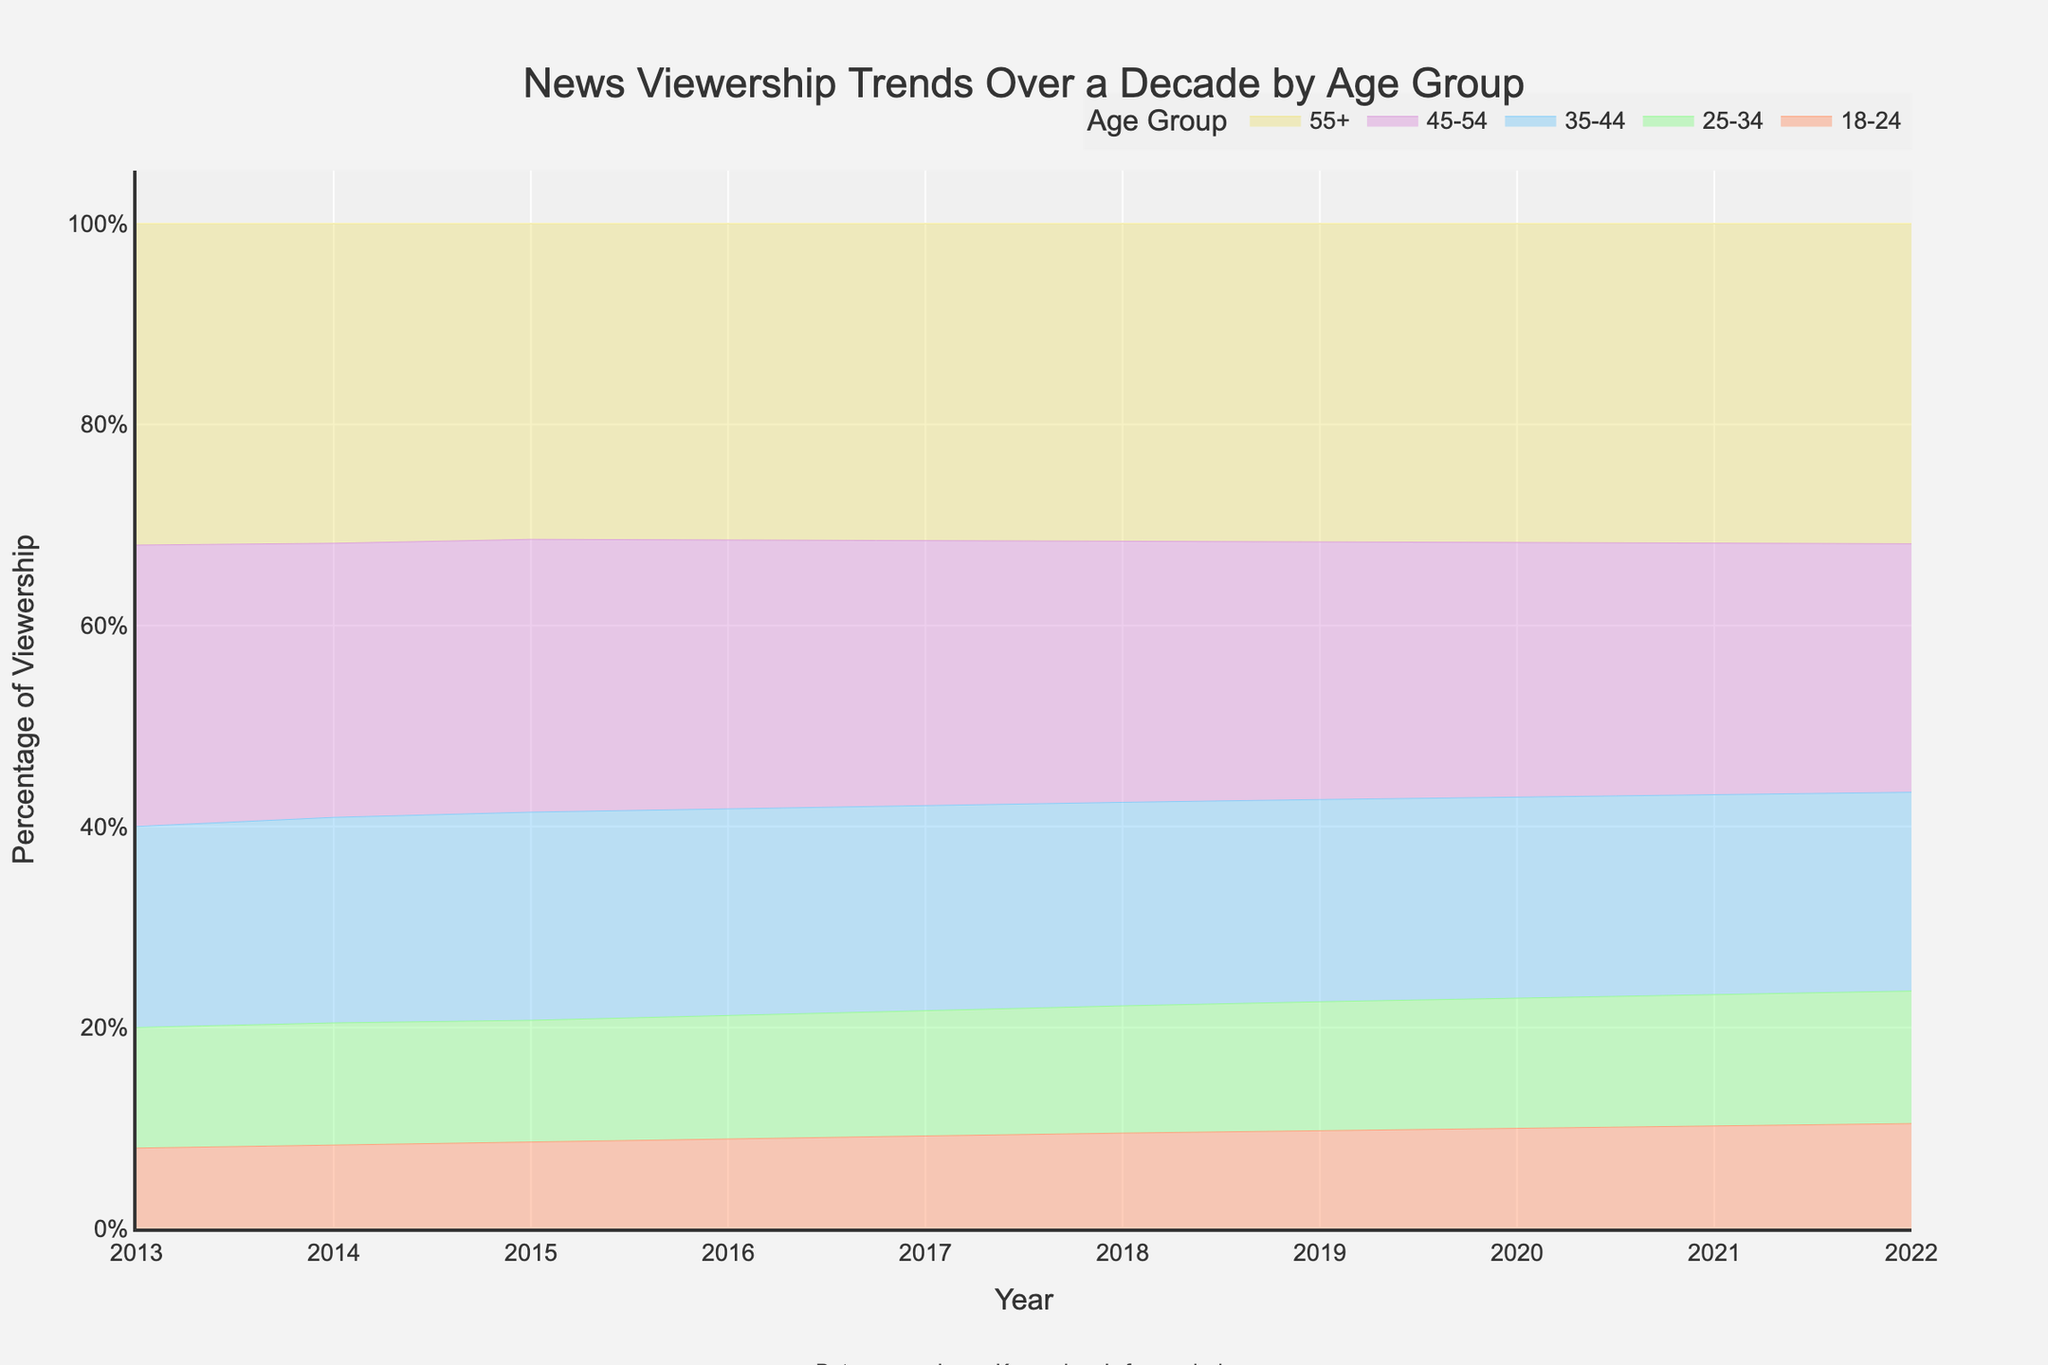what is the title of the figure? The title is generally placed at the top of the figure. By quickly scanning the top area, you can read it directly.
Answer: News Viewership Trends Over a Decade by Age Group What is the percentage range for the age group 55+ in 2015? From the legend, we know that each color represents a different age group. By following the color corresponding to 55+, look at the 2015 data point to find the percentage.
Answer: 44% How does the viewership trend for the 18-24 age group change from 2013 to 2022? Track the color representing the 18-24 age group from the left (2013) to the right (2022) to identify how the trend changes over the years.
Answer: It increases from 10% to 19% Which age group had the most significant increase in viewership percentage from 2013 to 2022? Compare the end points for each age group from 2013 and 2022. Calculate the differences and identify the age group with the highest positive change.
Answer: 18-24 What was the viewership percentage for the 45-54 age group in 2020? Find the color corresponding to 45-54 and look at the percentage point in 2020.
Answer: 43% In which year did the 25-34 age group's viewership surpass the 18-24 age group? Compare the lines for 25-34 and 18-24 across the years. Observe where 25-34 first becomes higher than 18-24.
Answer: 2014 How did the overall trend of viewership percentages change over the dataset period? Sum the viewership percentages of all age groups for each year to see if the total percentage is increasing, decreasing, or stable over time.
Answer: Increasing What is the combined viewership percentage for the 25-34 and 35-44 age groups in 2018? Locate the percentages for 25-34 and 35-44 in 2018 and add them together for the combined percentage.
Answer: 20% + 32% = 52% Which two age groups showed similar trends (absolute percentage values) over the decade? By looking at each group's trend, identify which two lines appear to follow a similar growth or pattern over the years.
Answer: 45-54 and 55+ By how much did the viewership percentage for the 55+ age group grow from 2015 to 2018? Subtract the percentage in 2015 from the percentage in 2018 for the 55+ age group.
Answer: 50% - 44% = 6% 